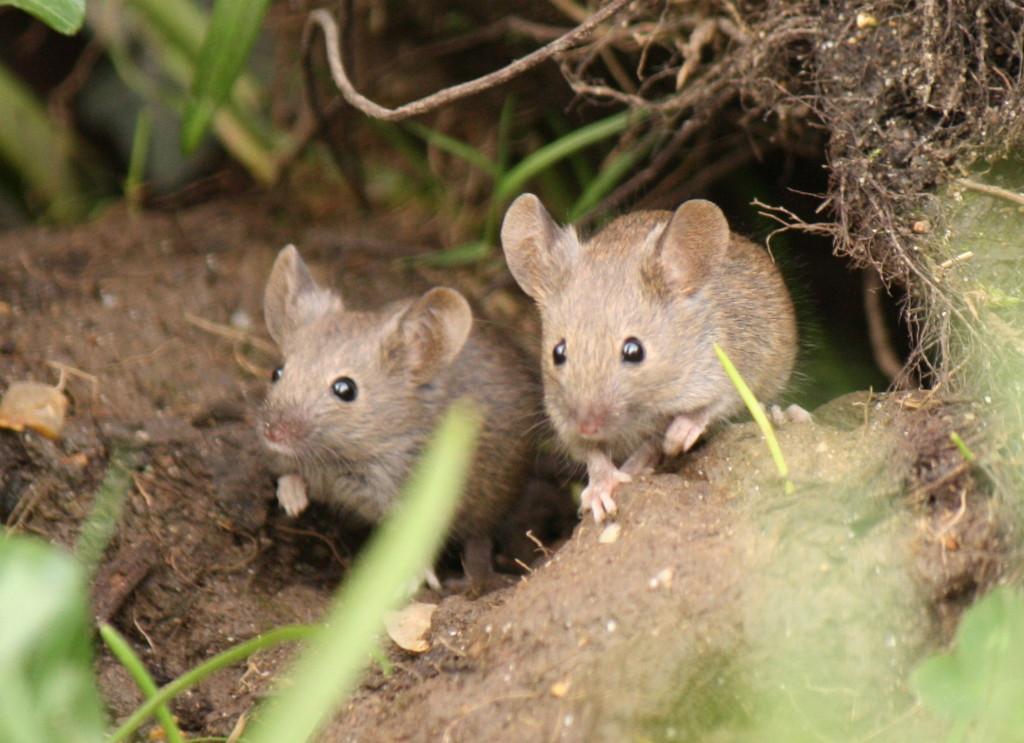Describe this image in one or two sentences. In this image we can see two mice on the ground. Here we can see leaves. 